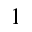Convert formula to latex. <formula><loc_0><loc_0><loc_500><loc_500>^ { 1 }</formula> 